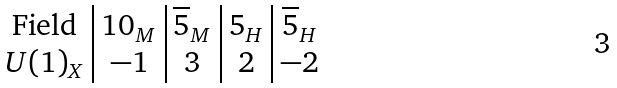<formula> <loc_0><loc_0><loc_500><loc_500>\begin{array} { c | c | c | c | c } \text {Field} & 1 0 _ { M } & \overline { 5 } _ { M } & 5 _ { H } & \overline { 5 } _ { H } \\ U ( 1 ) _ { X } & - 1 & 3 & 2 & - 2 \end{array}</formula> 